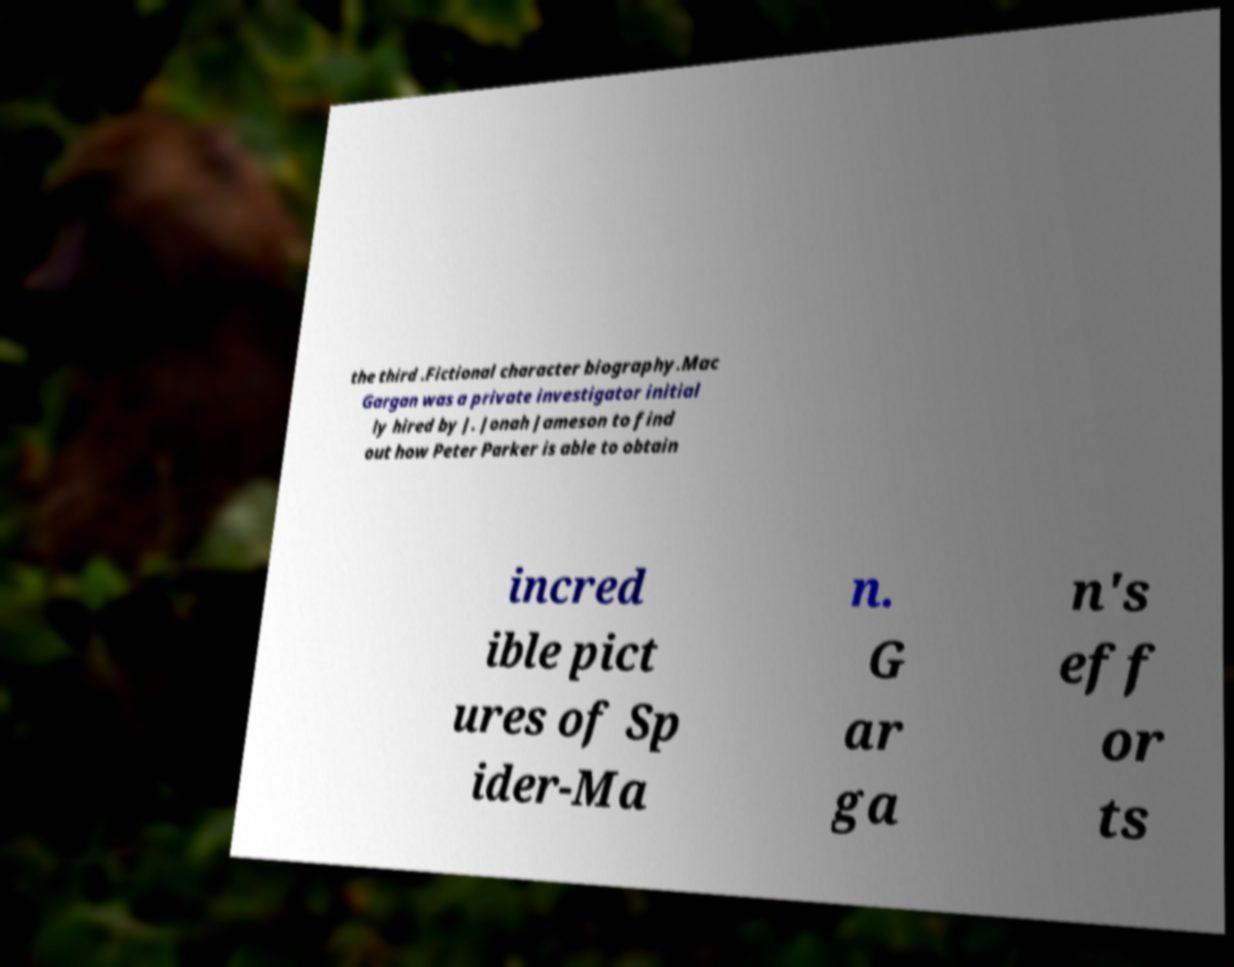What messages or text are displayed in this image? I need them in a readable, typed format. the third .Fictional character biography.Mac Gargan was a private investigator initial ly hired by J. Jonah Jameson to find out how Peter Parker is able to obtain incred ible pict ures of Sp ider-Ma n. G ar ga n's eff or ts 